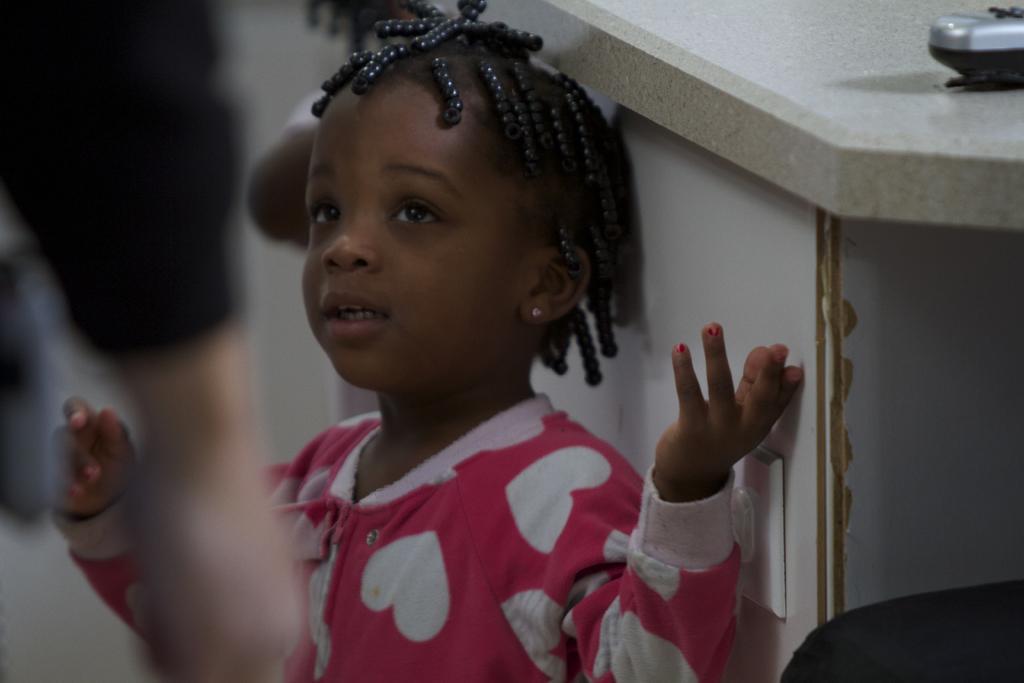Can you describe this image briefly? In the foreground of this image, there is a girl. On the left, there is a person's hand. In the right bottom corner, there is a black color object and an object on the stone surface. We can also see another person in the background. 